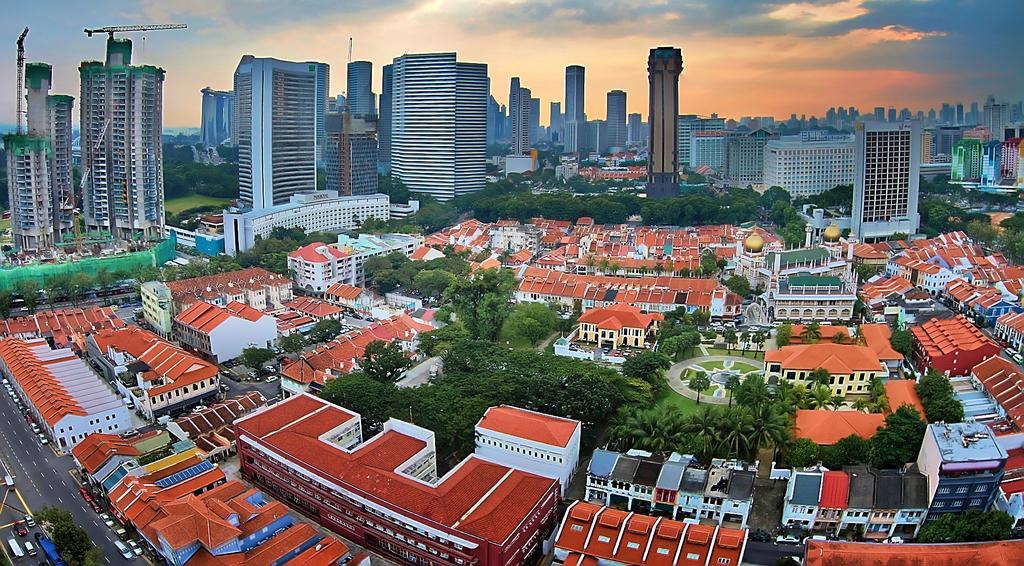Could you give a brief overview of what you see in this image? In this picture of a city. In this image there are buildings and trees and there are vehicles on the road. On the left side of the image there are cranes. At the top there is sky and there are clouds. At the bottom there is grass and there is a road. 